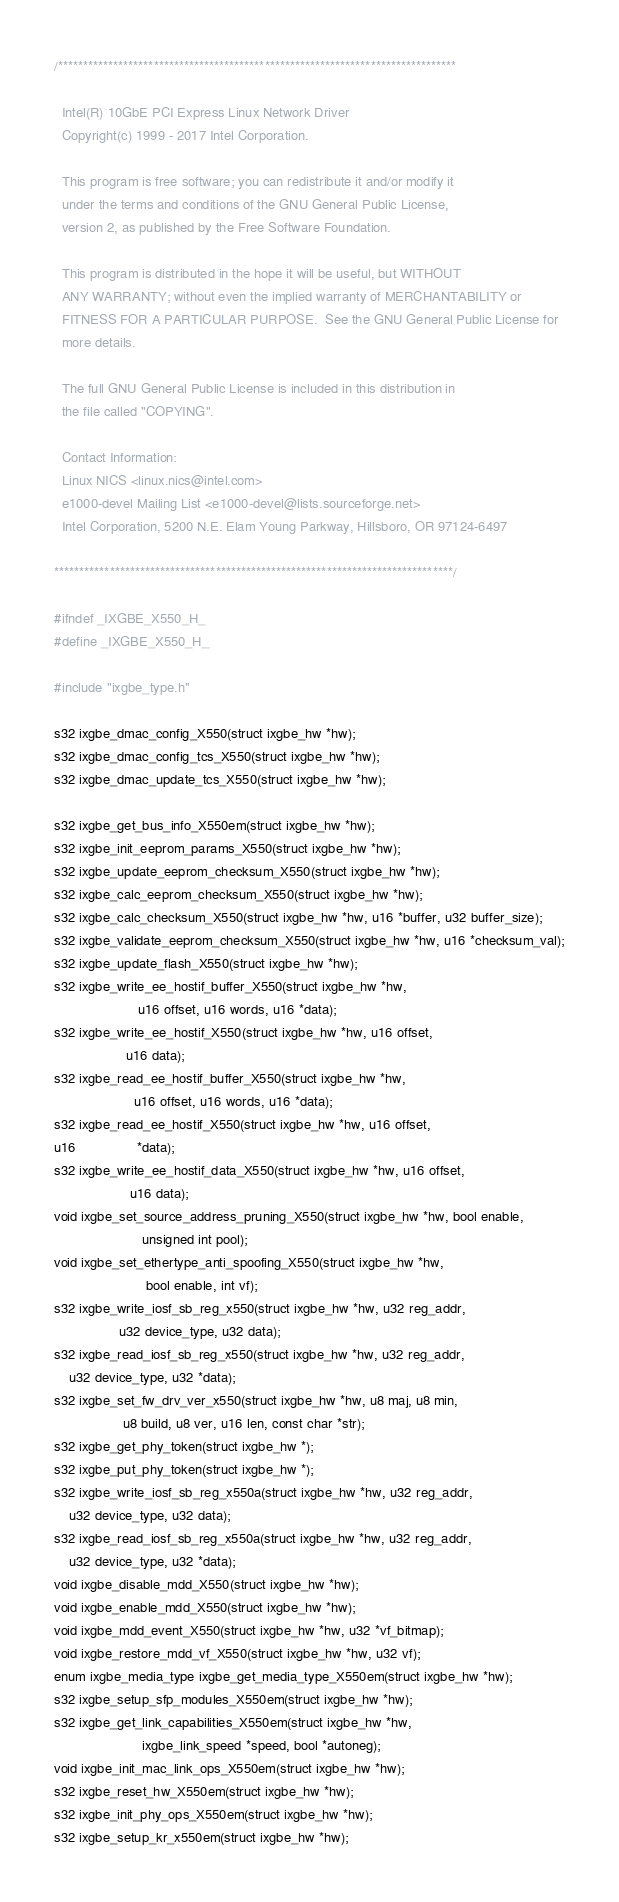Convert code to text. <code><loc_0><loc_0><loc_500><loc_500><_C_>/*******************************************************************************

  Intel(R) 10GbE PCI Express Linux Network Driver
  Copyright(c) 1999 - 2017 Intel Corporation.

  This program is free software; you can redistribute it and/or modify it
  under the terms and conditions of the GNU General Public License,
  version 2, as published by the Free Software Foundation.

  This program is distributed in the hope it will be useful, but WITHOUT
  ANY WARRANTY; without even the implied warranty of MERCHANTABILITY or
  FITNESS FOR A PARTICULAR PURPOSE.  See the GNU General Public License for
  more details.

  The full GNU General Public License is included in this distribution in
  the file called "COPYING".

  Contact Information:
  Linux NICS <linux.nics@intel.com>
  e1000-devel Mailing List <e1000-devel@lists.sourceforge.net>
  Intel Corporation, 5200 N.E. Elam Young Parkway, Hillsboro, OR 97124-6497

*******************************************************************************/

#ifndef _IXGBE_X550_H_
#define _IXGBE_X550_H_

#include "ixgbe_type.h"

s32 ixgbe_dmac_config_X550(struct ixgbe_hw *hw);
s32 ixgbe_dmac_config_tcs_X550(struct ixgbe_hw *hw);
s32 ixgbe_dmac_update_tcs_X550(struct ixgbe_hw *hw);

s32 ixgbe_get_bus_info_X550em(struct ixgbe_hw *hw);
s32 ixgbe_init_eeprom_params_X550(struct ixgbe_hw *hw);
s32 ixgbe_update_eeprom_checksum_X550(struct ixgbe_hw *hw);
s32 ixgbe_calc_eeprom_checksum_X550(struct ixgbe_hw *hw);
s32 ixgbe_calc_checksum_X550(struct ixgbe_hw *hw, u16 *buffer, u32 buffer_size);
s32 ixgbe_validate_eeprom_checksum_X550(struct ixgbe_hw *hw, u16 *checksum_val);
s32 ixgbe_update_flash_X550(struct ixgbe_hw *hw);
s32 ixgbe_write_ee_hostif_buffer_X550(struct ixgbe_hw *hw,
				      u16 offset, u16 words, u16 *data);
s32 ixgbe_write_ee_hostif_X550(struct ixgbe_hw *hw, u16 offset,
			       u16 data);
s32 ixgbe_read_ee_hostif_buffer_X550(struct ixgbe_hw *hw,
				     u16 offset, u16 words, u16 *data);
s32 ixgbe_read_ee_hostif_X550(struct ixgbe_hw *hw, u16 offset,
u16				*data);
s32 ixgbe_write_ee_hostif_data_X550(struct ixgbe_hw *hw, u16 offset,
				    u16 data);
void ixgbe_set_source_address_pruning_X550(struct ixgbe_hw *hw, bool enable,
					   unsigned int pool);
void ixgbe_set_ethertype_anti_spoofing_X550(struct ixgbe_hw *hw,
					    bool enable, int vf);
s32 ixgbe_write_iosf_sb_reg_x550(struct ixgbe_hw *hw, u32 reg_addr,
				 u32 device_type, u32 data);
s32 ixgbe_read_iosf_sb_reg_x550(struct ixgbe_hw *hw, u32 reg_addr,
	u32 device_type, u32 *data);
s32 ixgbe_set_fw_drv_ver_x550(struct ixgbe_hw *hw, u8 maj, u8 min,
			      u8 build, u8 ver, u16 len, const char *str);
s32 ixgbe_get_phy_token(struct ixgbe_hw *);
s32 ixgbe_put_phy_token(struct ixgbe_hw *);
s32 ixgbe_write_iosf_sb_reg_x550a(struct ixgbe_hw *hw, u32 reg_addr,
	u32 device_type, u32 data);
s32 ixgbe_read_iosf_sb_reg_x550a(struct ixgbe_hw *hw, u32 reg_addr,
	u32 device_type, u32 *data);
void ixgbe_disable_mdd_X550(struct ixgbe_hw *hw);
void ixgbe_enable_mdd_X550(struct ixgbe_hw *hw);
void ixgbe_mdd_event_X550(struct ixgbe_hw *hw, u32 *vf_bitmap);
void ixgbe_restore_mdd_vf_X550(struct ixgbe_hw *hw, u32 vf);
enum ixgbe_media_type ixgbe_get_media_type_X550em(struct ixgbe_hw *hw);
s32 ixgbe_setup_sfp_modules_X550em(struct ixgbe_hw *hw);
s32 ixgbe_get_link_capabilities_X550em(struct ixgbe_hw *hw,
				       ixgbe_link_speed *speed, bool *autoneg);
void ixgbe_init_mac_link_ops_X550em(struct ixgbe_hw *hw);
s32 ixgbe_reset_hw_X550em(struct ixgbe_hw *hw);
s32 ixgbe_init_phy_ops_X550em(struct ixgbe_hw *hw);
s32 ixgbe_setup_kr_x550em(struct ixgbe_hw *hw);</code> 